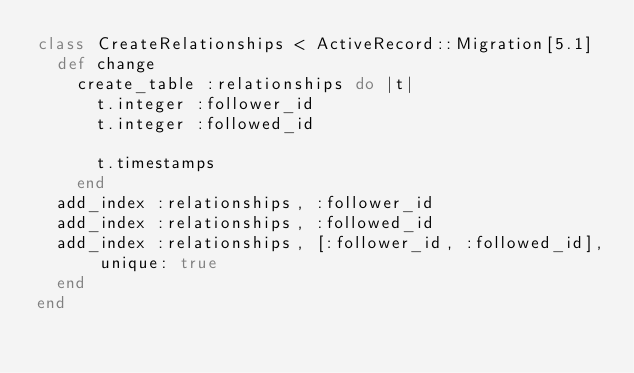<code> <loc_0><loc_0><loc_500><loc_500><_Ruby_>class CreateRelationships < ActiveRecord::Migration[5.1]
  def change
    create_table :relationships do |t|
      t.integer :follower_id
      t.integer :followed_id

      t.timestamps
    end
  add_index :relationships, :follower_id
  add_index :relationships, :followed_id
  add_index :relationships, [:follower_id, :followed_id], unique: true
  end
end
</code> 